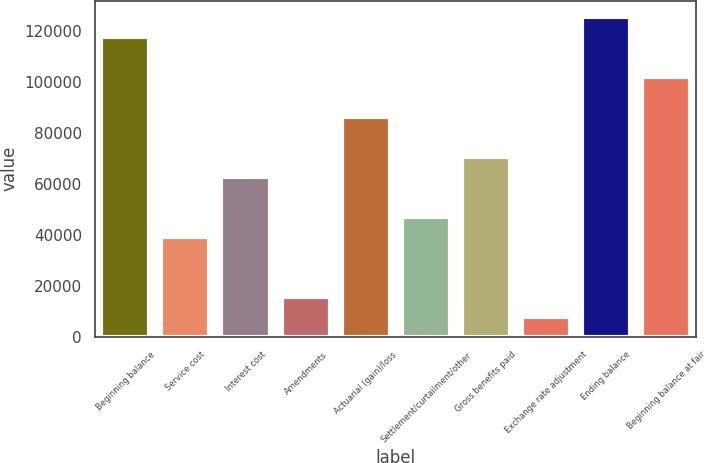<chart> <loc_0><loc_0><loc_500><loc_500><bar_chart><fcel>Beginning balance<fcel>Service cost<fcel>Interest cost<fcel>Amendments<fcel>Actuarial (gain)/loss<fcel>Settlement/curtailment/other<fcel>Gross benefits paid<fcel>Exchange rate adjustment<fcel>Ending balance<fcel>Beginning balance at fair<nl><fcel>117584<fcel>39198.5<fcel>62714<fcel>15683<fcel>86229.5<fcel>47037<fcel>70552.5<fcel>7844.5<fcel>125422<fcel>101906<nl></chart> 